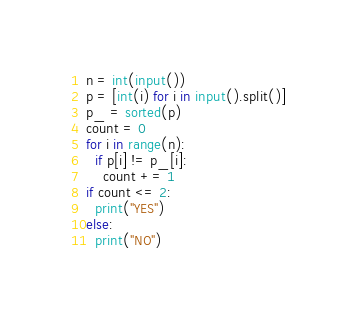<code> <loc_0><loc_0><loc_500><loc_500><_Python_>n = int(input())
p = [int(i) for i in input().split()] 
p_ = sorted(p)
count = 0
for i in range(n):
  if p[i] != p_[i]:
    count += 1
if count <= 2:
  print("YES")
else:
  print("NO")</code> 